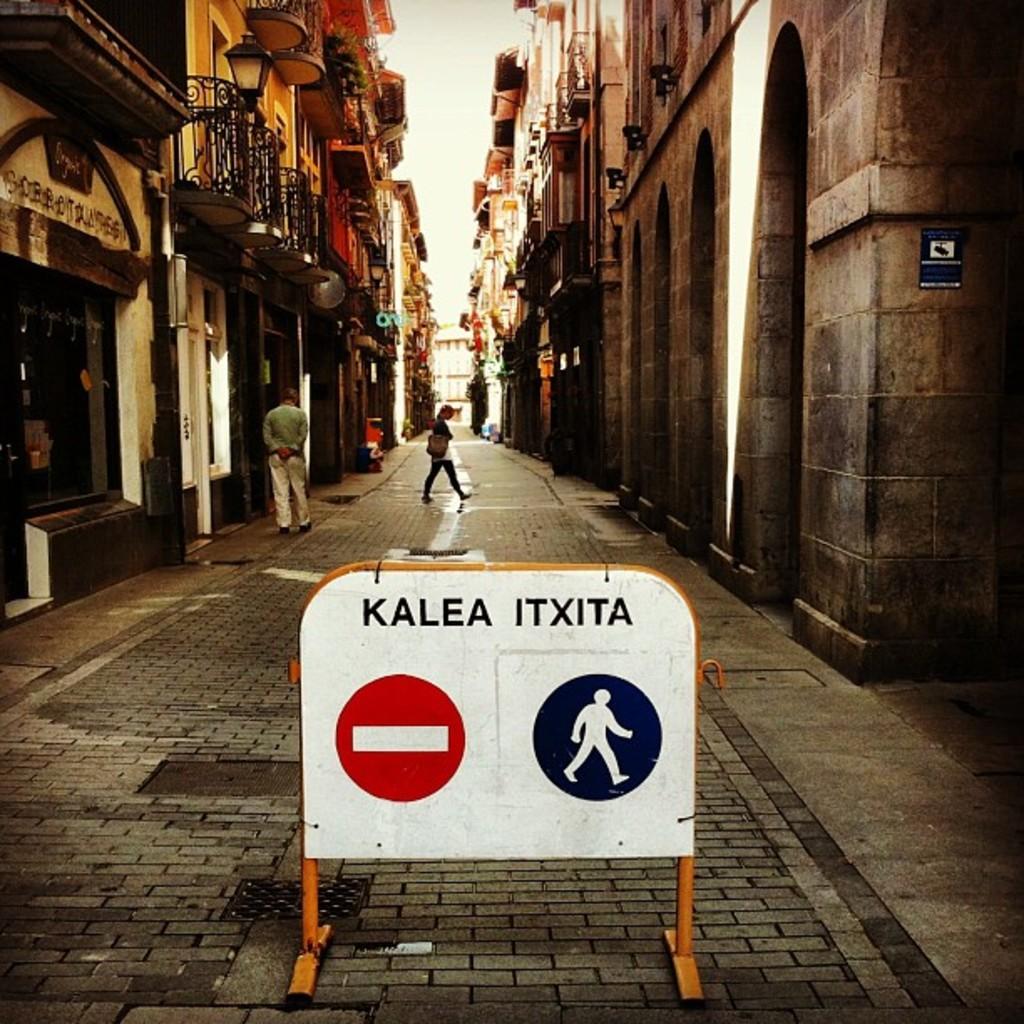What does the sign say?
Provide a succinct answer. Kalea itxita. What is the right word at the top?
Your answer should be very brief. Itxita. 